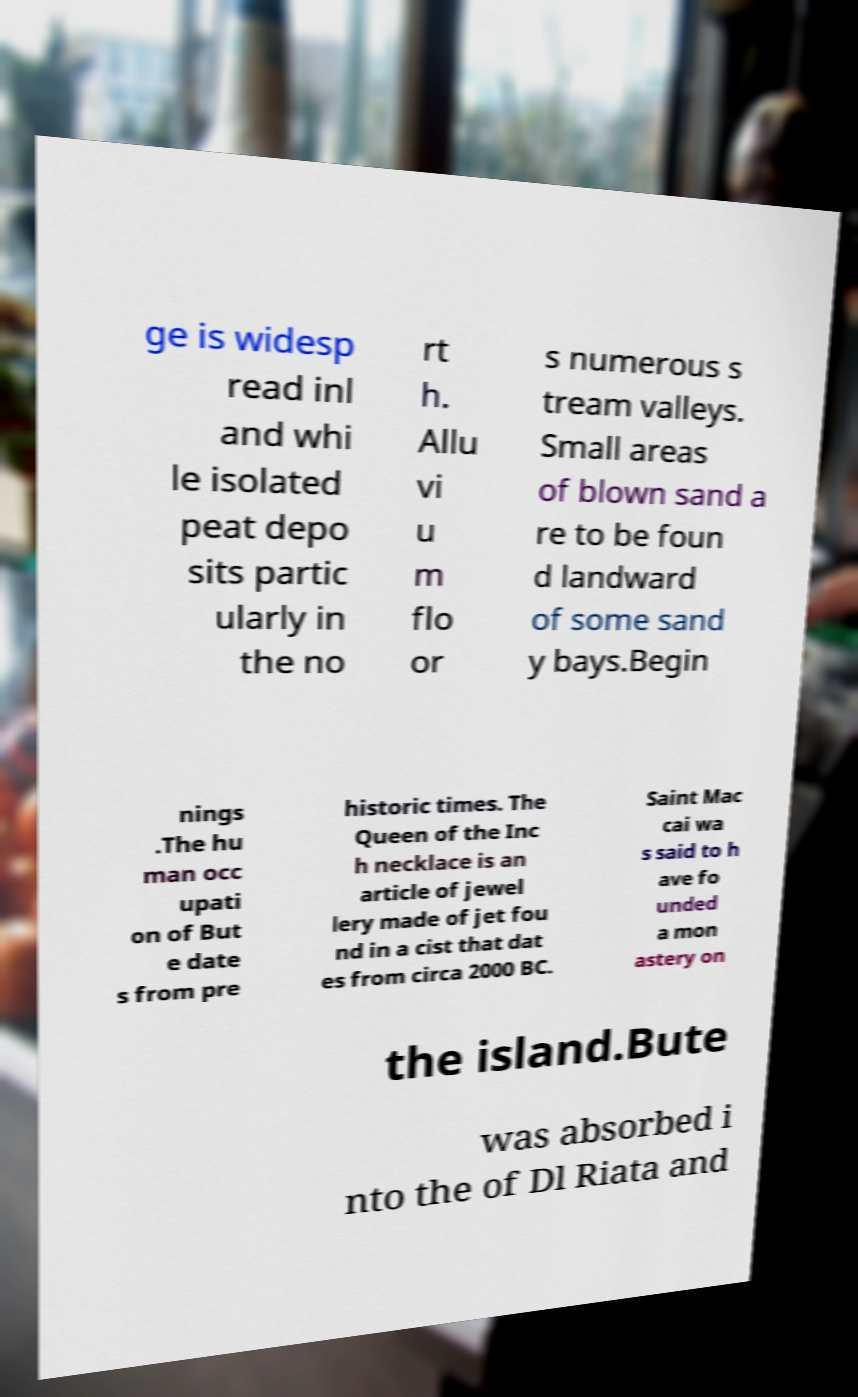Could you assist in decoding the text presented in this image and type it out clearly? ge is widesp read inl and whi le isolated peat depo sits partic ularly in the no rt h. Allu vi u m flo or s numerous s tream valleys. Small areas of blown sand a re to be foun d landward of some sand y bays.Begin nings .The hu man occ upati on of But e date s from pre historic times. The Queen of the Inc h necklace is an article of jewel lery made of jet fou nd in a cist that dat es from circa 2000 BC. Saint Mac cai wa s said to h ave fo unded a mon astery on the island.Bute was absorbed i nto the of Dl Riata and 